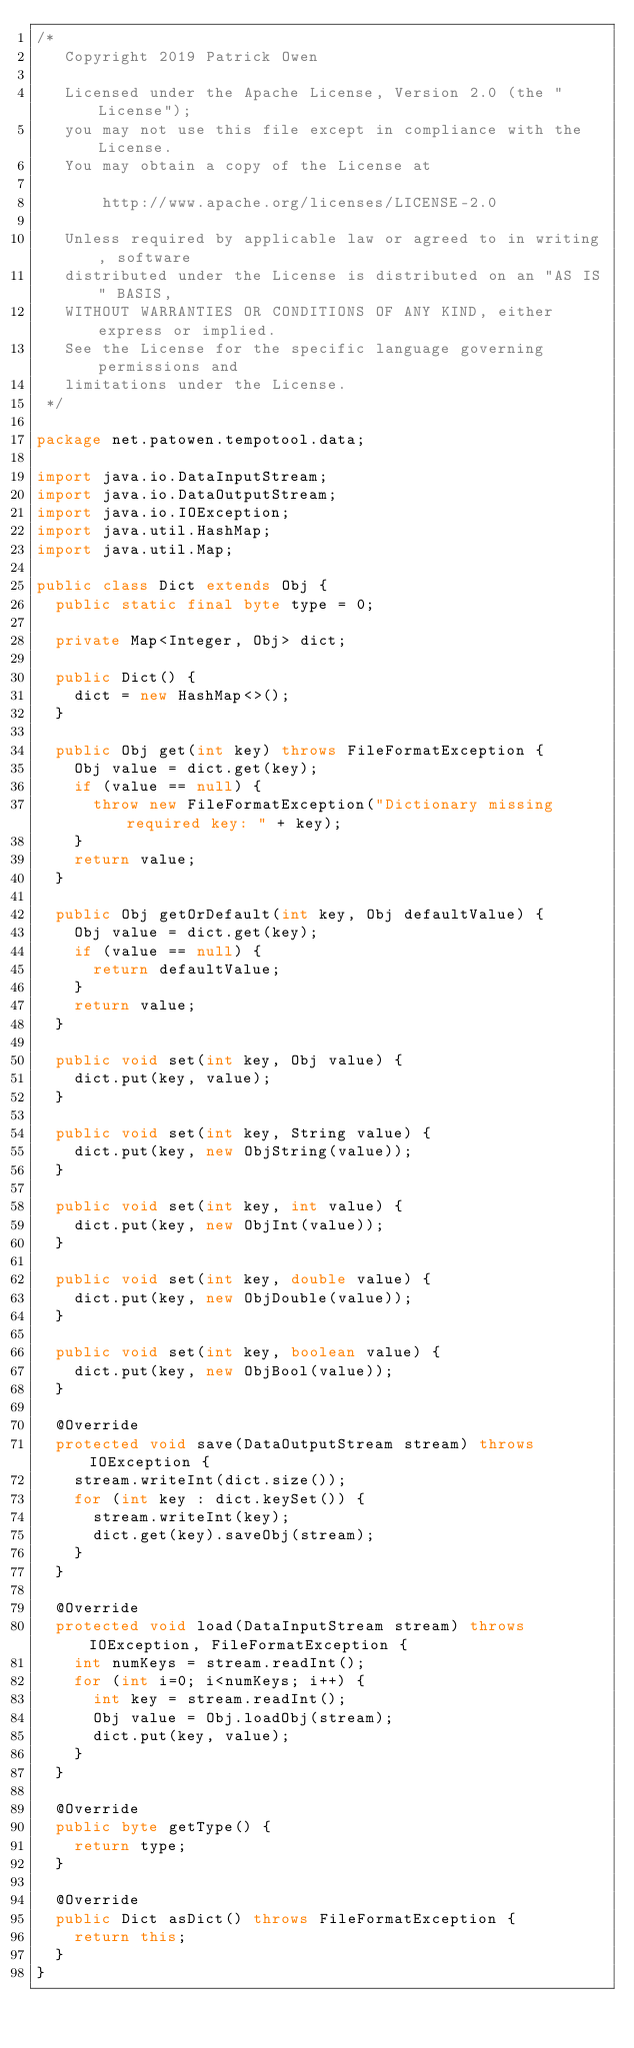Convert code to text. <code><loc_0><loc_0><loc_500><loc_500><_Java_>/*
   Copyright 2019 Patrick Owen

   Licensed under the Apache License, Version 2.0 (the "License");
   you may not use this file except in compliance with the License.
   You may obtain a copy of the License at

       http://www.apache.org/licenses/LICENSE-2.0

   Unless required by applicable law or agreed to in writing, software
   distributed under the License is distributed on an "AS IS" BASIS,
   WITHOUT WARRANTIES OR CONDITIONS OF ANY KIND, either express or implied.
   See the License for the specific language governing permissions and
   limitations under the License.
 */

package net.patowen.tempotool.data;

import java.io.DataInputStream;
import java.io.DataOutputStream;
import java.io.IOException;
import java.util.HashMap;
import java.util.Map;

public class Dict extends Obj {
	public static final byte type = 0;
	
	private Map<Integer, Obj> dict;
	
	public Dict() {
		dict = new HashMap<>();
	}
	
	public Obj get(int key) throws FileFormatException {
		Obj value = dict.get(key);
		if (value == null) {
			throw new FileFormatException("Dictionary missing required key: " + key);
		}
		return value;
	}
	
	public Obj getOrDefault(int key, Obj defaultValue) {
		Obj value = dict.get(key);
		if (value == null) {
			return defaultValue;
		}
		return value;
	}
	
	public void set(int key, Obj value) {
		dict.put(key, value);
	}
	
	public void set(int key, String value) {
		dict.put(key, new ObjString(value));
	}
	
	public void set(int key, int value) {
		dict.put(key, new ObjInt(value));
	}
	
	public void set(int key, double value) {
		dict.put(key, new ObjDouble(value));
	}
	
	public void set(int key, boolean value) {
		dict.put(key, new ObjBool(value));
	}
	
	@Override
	protected void save(DataOutputStream stream) throws IOException {
		stream.writeInt(dict.size());
		for (int key : dict.keySet()) {
			stream.writeInt(key);
			dict.get(key).saveObj(stream);
		}
	}
	
	@Override
	protected void load(DataInputStream stream) throws IOException, FileFormatException {
		int numKeys = stream.readInt();
		for (int i=0; i<numKeys; i++) {
			int key = stream.readInt();
			Obj value = Obj.loadObj(stream);
			dict.put(key, value);
		}
	}
	
	@Override
	public byte getType() {
		return type;
	}
	
	@Override
	public Dict asDict() throws FileFormatException {
		return this;
	}
}
</code> 